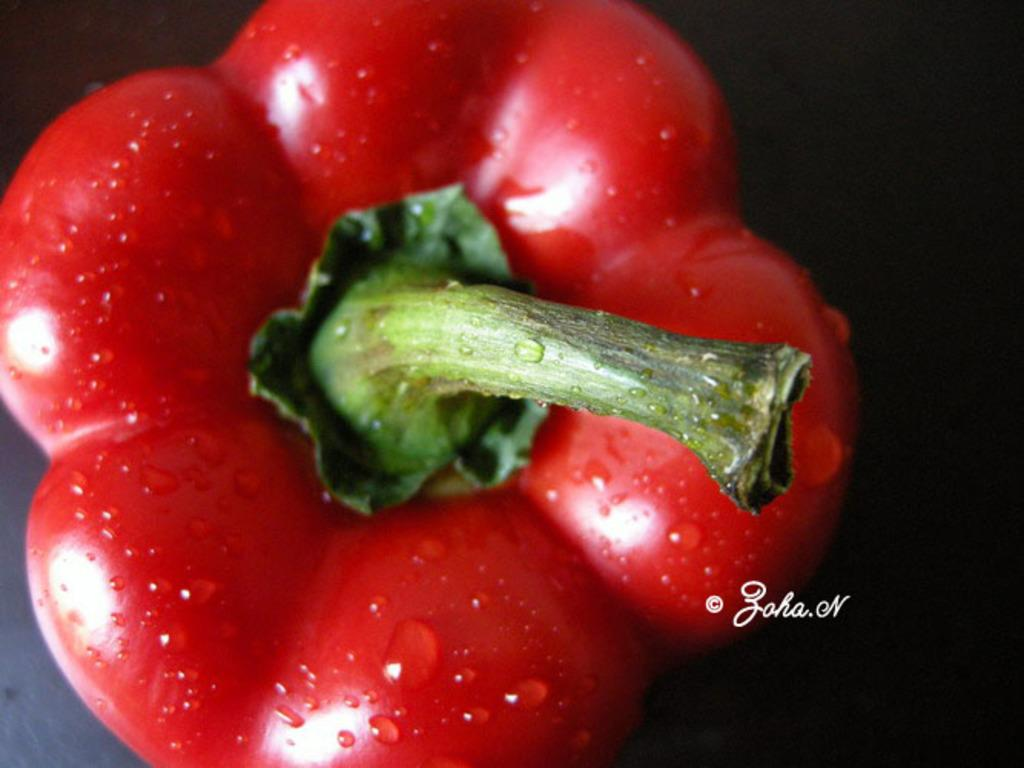What type of vegetable is in the image? There is a red bell pepper in the image. Can you describe the appearance of the bell pepper? There are water drops on the bell pepper. What else is present in the image besides the bell pepper? There is edited text on the right side of the image. What type of juice can be seen coming out of the bell pepper in the image? There is no juice coming out of the bell pepper in the image. 